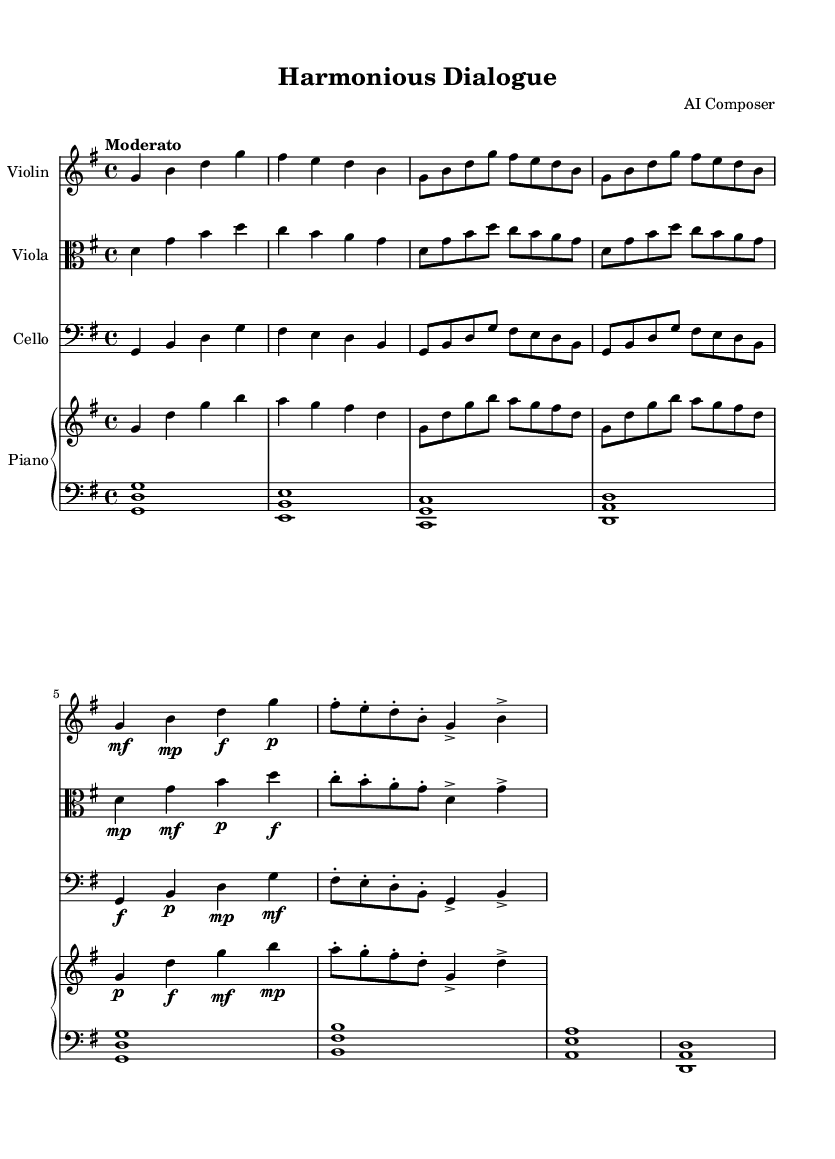what is the key signature of this music? The key signature is G major, which has one sharp (F#). This can be determined by looking at the key signature that appears at the beginning of the staff.
Answer: G major what is the time signature of this music? The time signature displayed at the beginning of the score is 4/4, indicating four beats in each measure. This is visible in the notation right after the key signature.
Answer: 4/4 what is the tempo marking for this composition? The tempo marking is "Moderato," which indicates a moderate walking pace for performance. This is written above the staff.
Answer: Moderato how many instruments are involved in this composition? The composition involves four instruments: Violin, Viola, Cello, and Piano. This is determined by the number of staves and their respective instrument names indicated at the beginning of each staff.
Answer: four which instruments play the same melody in the first eight measures? The Violin and Cello play the same melody in the first eight measures. Analyzing the melodic lines reveals that the passages for these instruments are identical during that section.
Answer: Violin and Cello describe the dynamic markings for the Viola in the first half of the piece. The dynamic markings for the Viola indicate a range from mezzo-piano (mp) to forte (f) as the music progresses. The specific markings can be found placed above or below the staff within the measures.
Answer: mp to f what does the use of parallel motion in the piano signify in this piece? The parallel motion in the piano typically signifies harmony and support for the melody, providing a cohesive background for the violin and viola. It enhances the texture and creates a balanced sound among all instruments.
Answer: harmony and support 